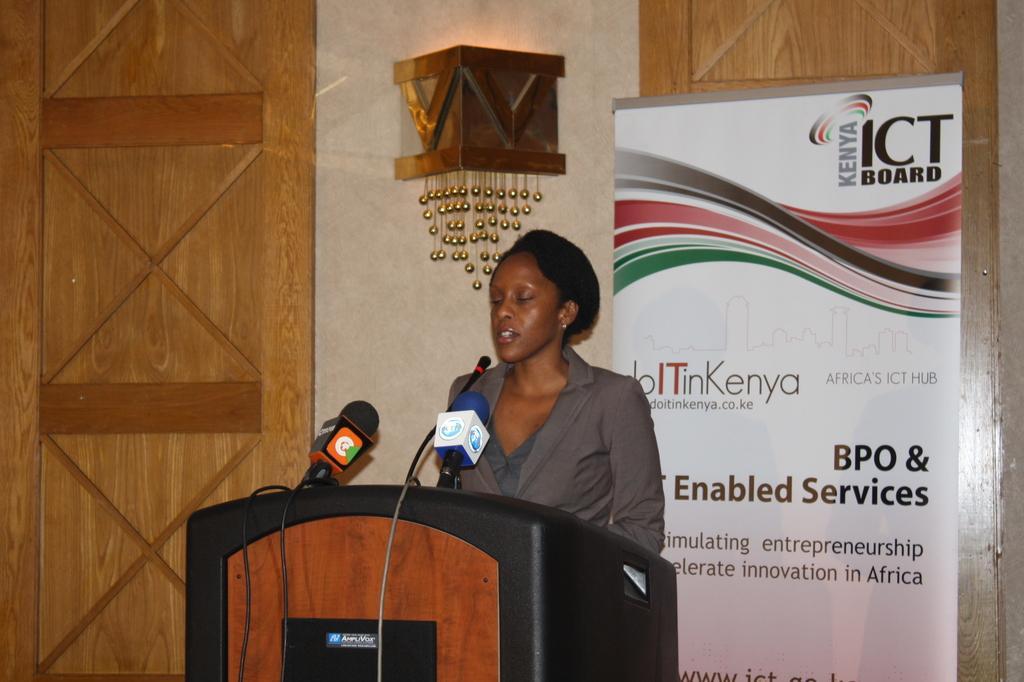Could you give a brief overview of what you see in this image? In this image I can see a woman standing in front of the podium and speaking on the microphone and two more miles are attached to this podium. At the back of her I can see a white color banner and also the wall. On the the left and the right side of the image I can see a wooden boards. 